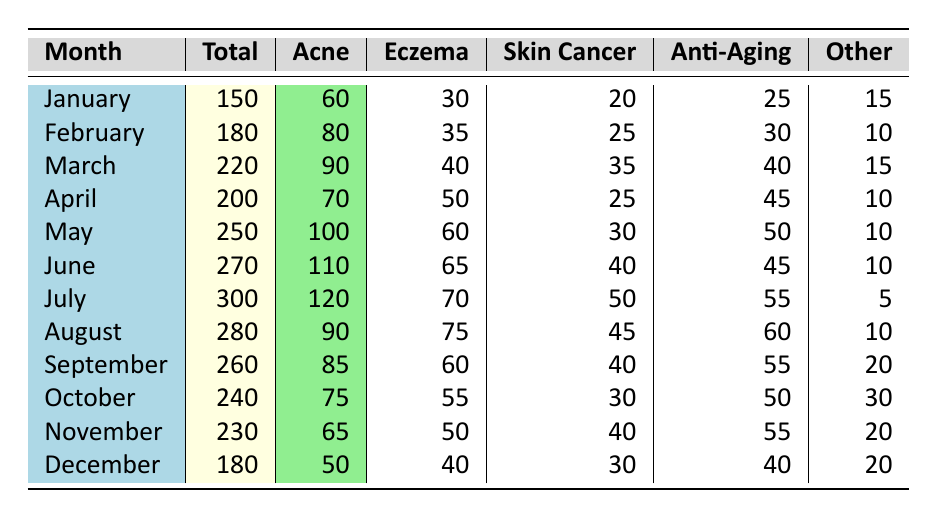What month had the highest total consultations? By looking at the total consultations column, July has the highest value of 300, which is greater than any other month listed.
Answer: July What was the total number of acne treatments in May? In the table, the row for May shows that there were 100 acne treatments administered.
Answer: 100 How many more consultations were there in June than in April? The total consultations for June is 270 and for April is 200. Therefore, the difference is 270 - 200 = 70 more consultations in June.
Answer: 70 Did the number of skin cancer screenings exceed 40 in any month? By checking the skin cancer screenings column, we can see values that are greater than 40 in March (35), July (50), and other months do not exceed 40. Thus, yes, the number of screenings exceeded 40 in those months.
Answer: Yes What was the average number of anti-aging procedures performed from January to June? The number of anti-aging procedures are: January (25), February (30), March (40), April (45), May (50), June (45). Summing these gives: 25 + 30 + 40 + 45 + 50 + 45 = 235. There are 6 months, so the average is 235 / 6 ≈ 39.17.
Answer: Approximately 39.17 Which month had the least number of consultations, and how many were there? When reviewing the total consultations, December shows the least with 180 consultations.
Answer: December, 180 What is the total number of eczema cases from July to September? The eczema cases are: July (70), August (75), September (60). Adding these gives: 70 + 75 + 60 = 205.
Answer: 205 Was the total number of acne treatments higher in any month than the total number of other conditions? By comparing the acne treatments to the other conditions across all months, July (120 acne) is higher than all the values in the "Other" column with a maximum of 30. Therefore, yes, July is an example where acne treatments were higher than other conditions.
Answer: Yes What was the monthly trend for total consultations from January to July? Total consultations increased consistently from January (150) to July (300). The numbers are as follows: January (150), February (180), March (220), April (200), May (250), June (270), July (300), showing an increase in consultations month-over-month consistently except for April which had a slight decline.
Answer: Consistently increasing, with a slight decline in April 